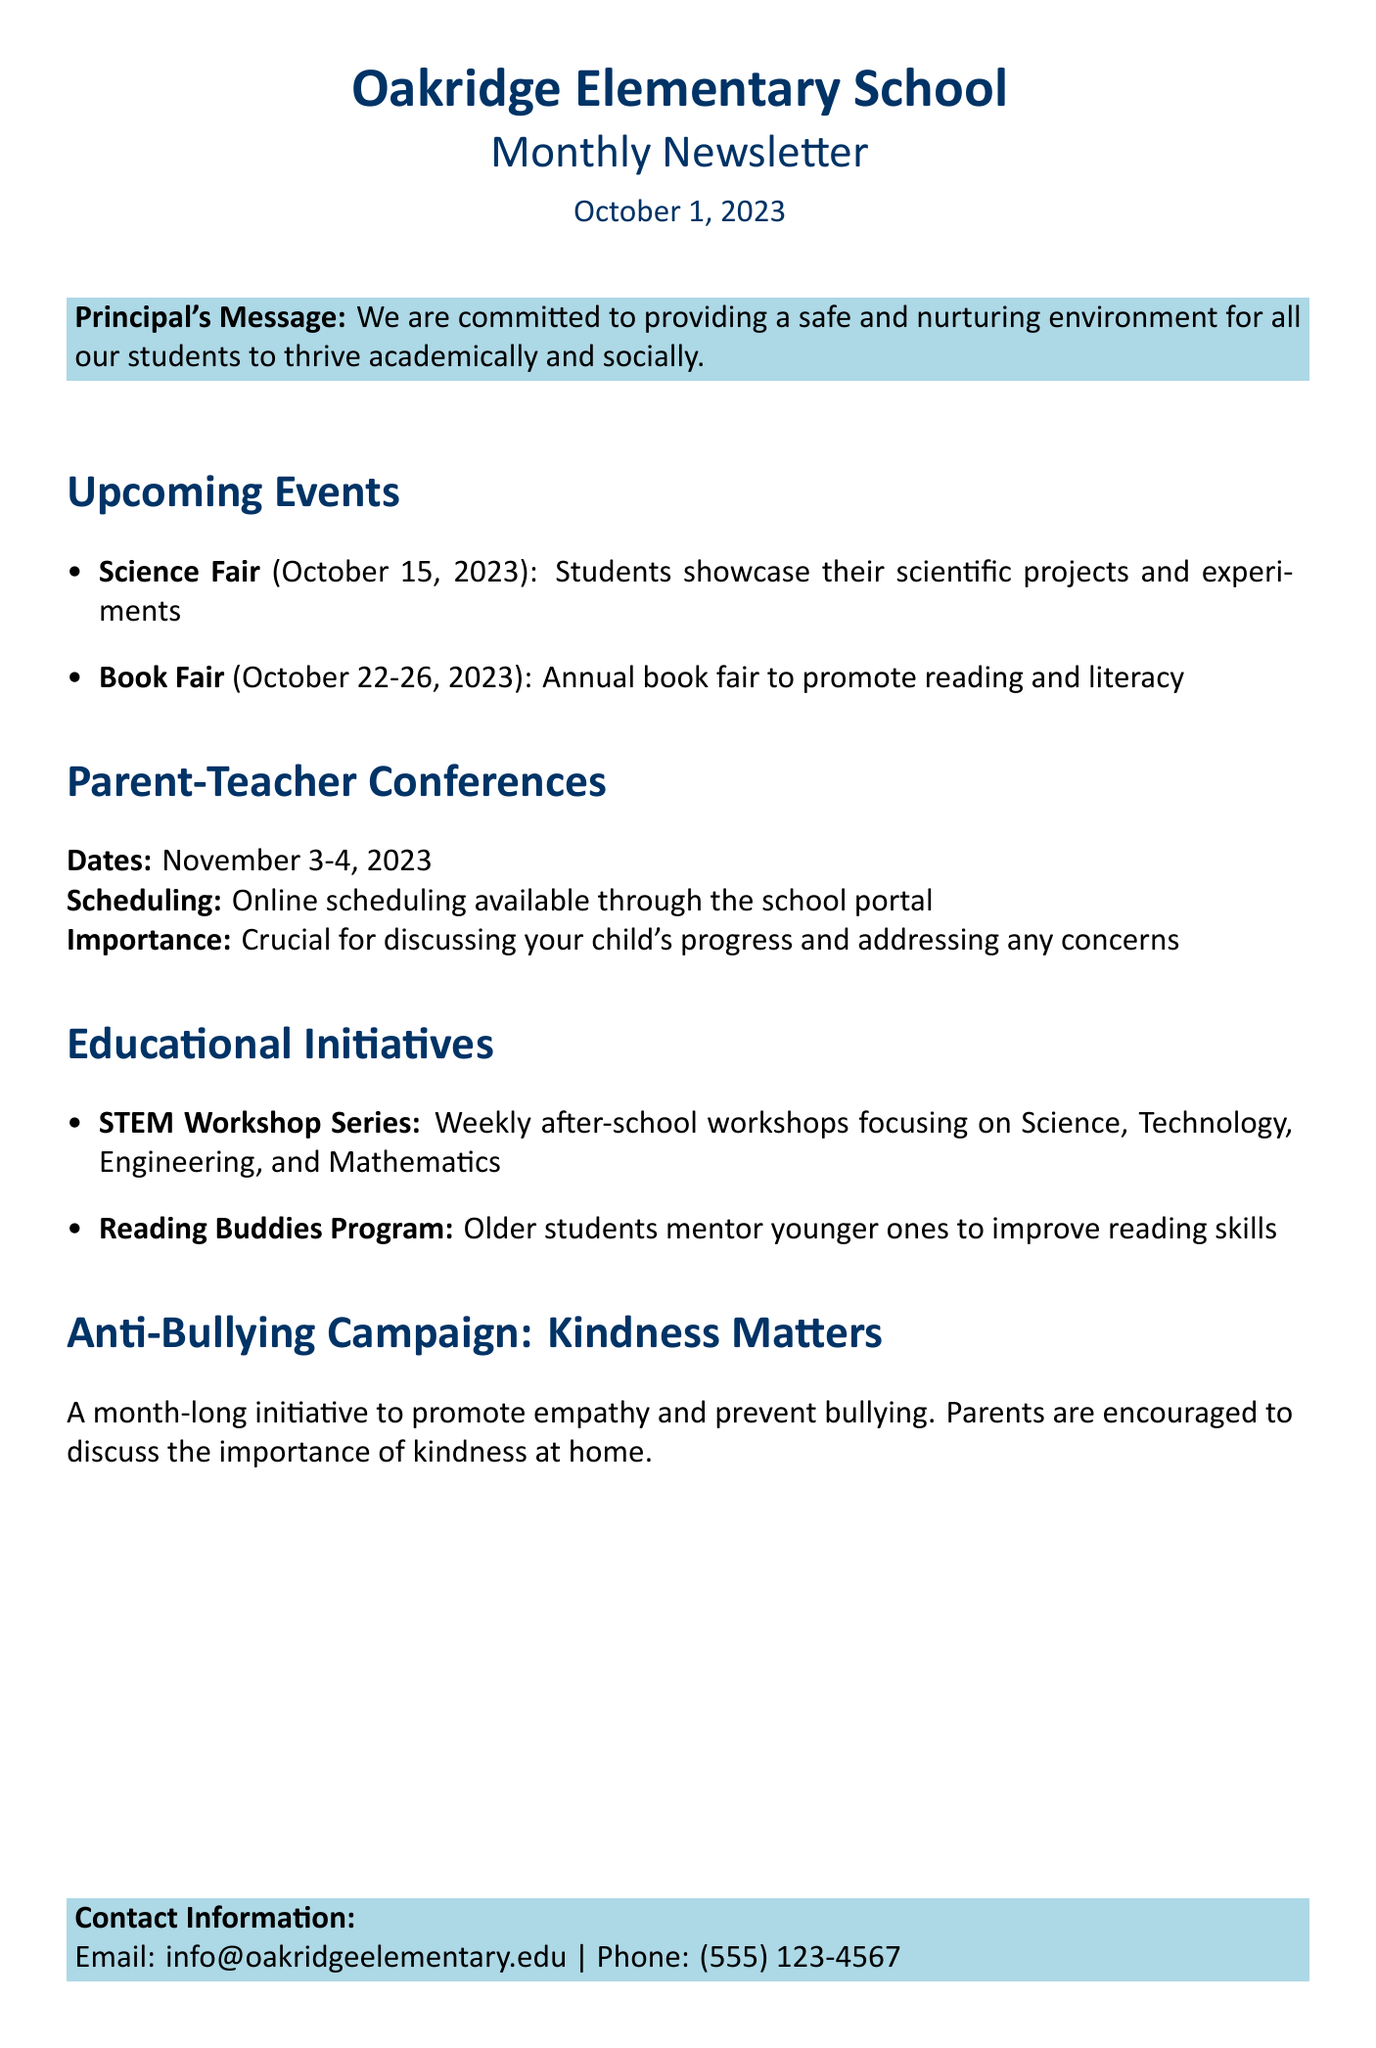what is the name of the school? The name of the school is mentioned at the beginning of the newsletter.
Answer: Oakridge Elementary School what is the date of the science fair? The date for the science fair is provided in the upcoming events section.
Answer: October 15, 2023 what are the dates for the parent-teacher conferences? The dates for the parent-teacher conferences are specified in that section of the newsletter.
Answer: November 3-4, 2023 what is the main focus of the STEM Workshop Series? The focus of the STEM Workshop Series is described in the educational initiatives section.
Answer: Science, Technology, Engineering, and Mathematics what is the name of the anti-bullying campaign? The name of the anti-bullying campaign is mentioned in the document.
Answer: Kindness Matters how long will the book fair run? The duration of the book fair is indicated in the upcoming events section.
Answer: October 22-26, 2023 how can parents schedule conferences? The method for scheduling conferences is outlined in the parent-teacher conferences section.
Answer: Online scheduling available through the school portal what is the importance of attending parent-teacher conferences? The importance of attending is explained in the respective section of the newsletter.
Answer: Crucial for discussing your child's progress and addressing any concerns what should parents discuss at home during the anti-bullying campaign? The document specifies what parents should talk about during the campaign.
Answer: Importance of kindness 